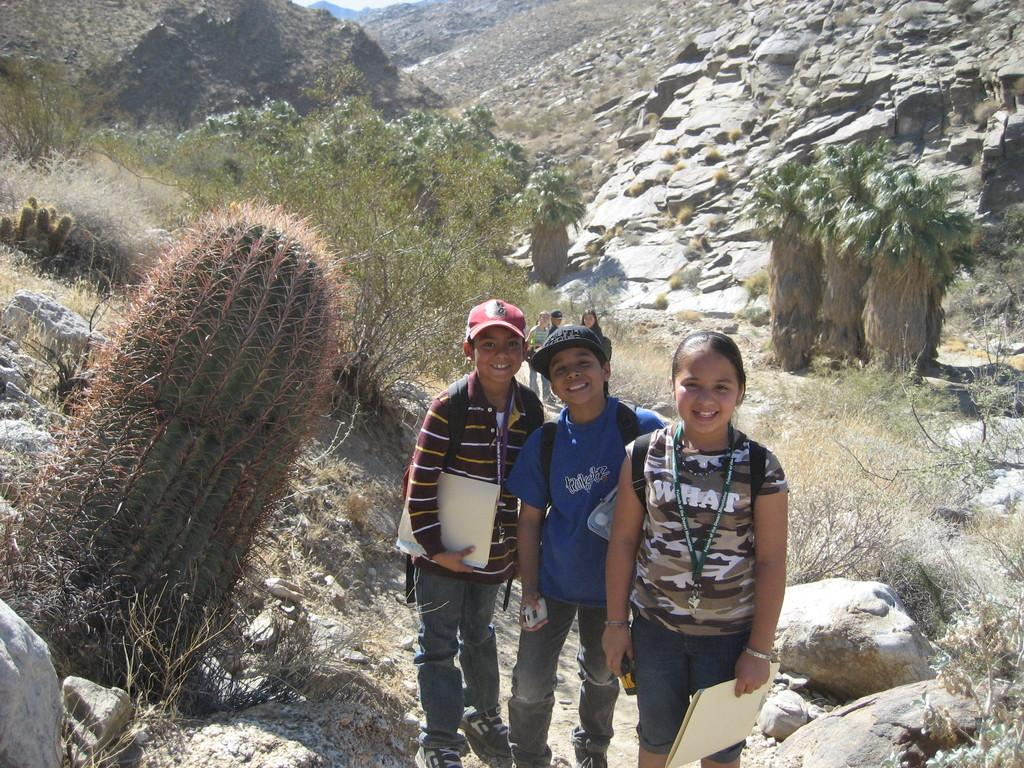How many people are in the group in the image? There is a group of people in the image, but the exact number is not specified. What is the facial expression of some people in the group? Some people in the group are smiling. What type of headwear can be seen on some people in the group? Some people in the group are wearing caps. What type of natural features are visible in the image? Trees, rocks, and hills are visible in the image. What is the setting of the image? The image appears to be set in a natural environment with trees, rocks, and hills visible in the background. What type of brick is used to construct the straw in the image? There is no brick or straw present in the image; it features a group of people in a natural environment. 